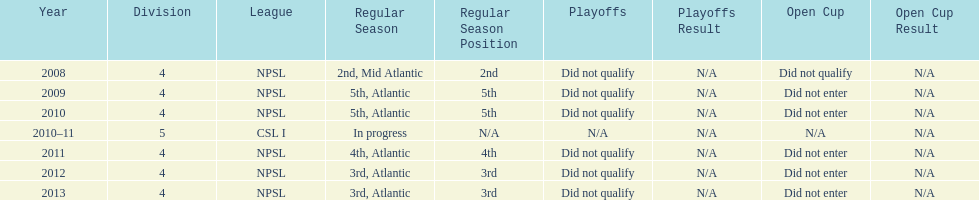What was the last year they were 5th? 2010. 